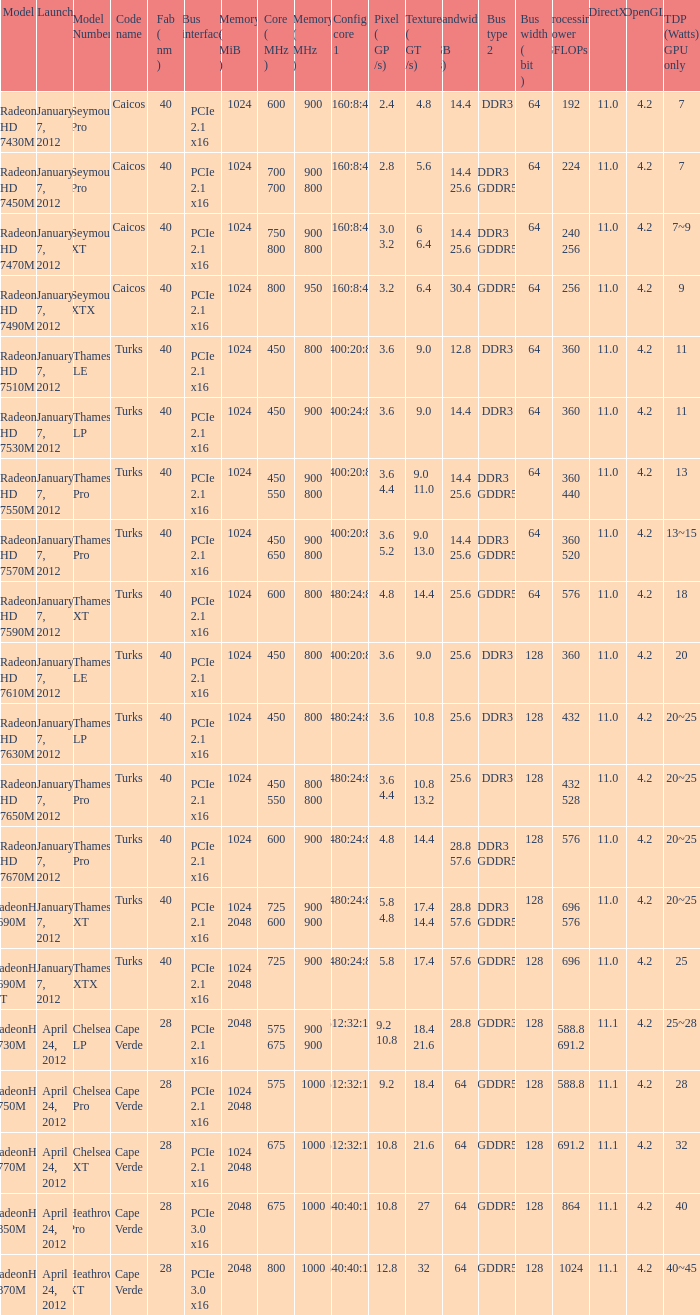If the gpu's tdp (watts) is 18, what is the number of texture (gt/s) the card possesses? 1.0. 